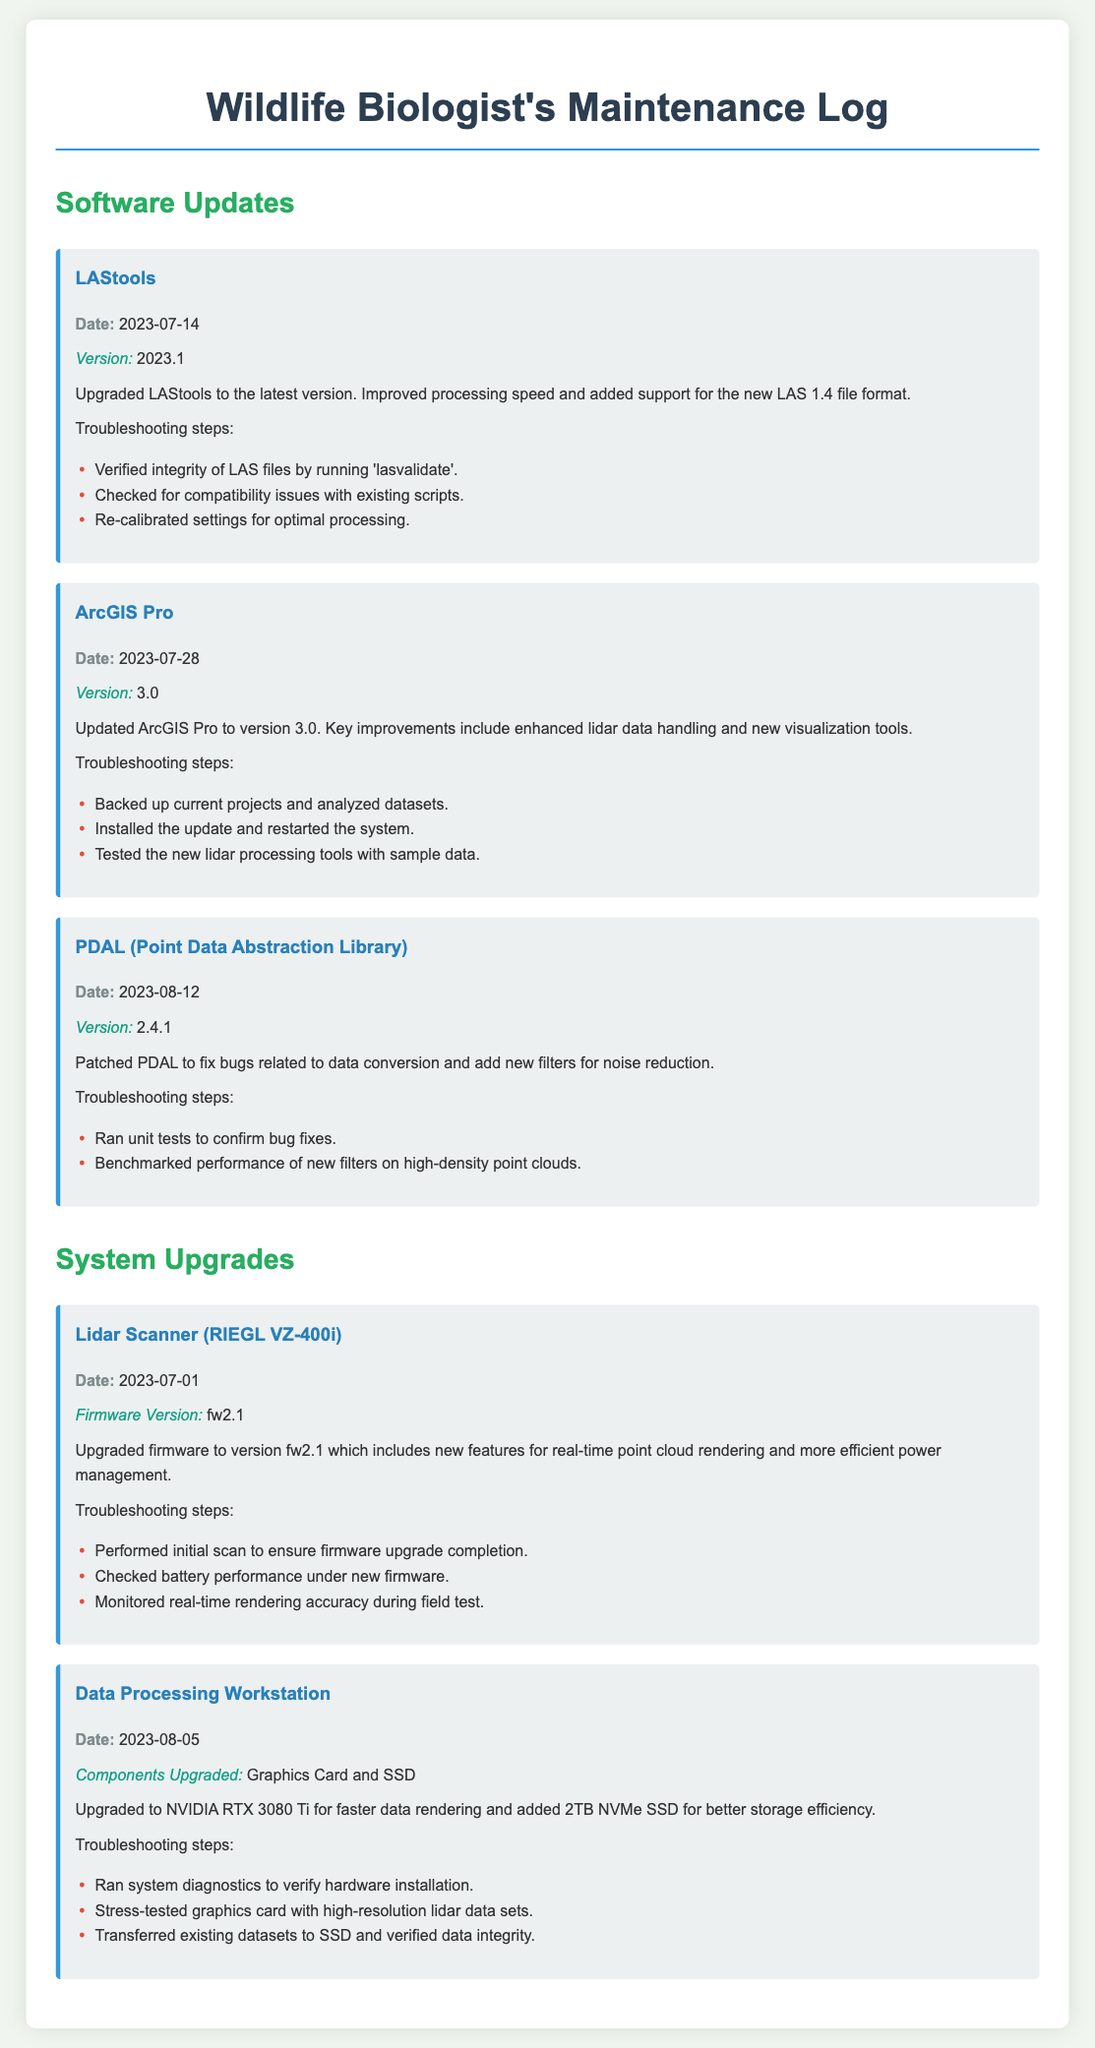what was the date of the LAStools upgrade? The LAStools upgrade is logged on July 14, 2023.
Answer: July 14, 2023 which version of ArcGIS Pro was installed? The document states that ArcGIS Pro was updated to version 3.0.
Answer: 3.0 what was the main improvement of the PDAL upgrade? The upgrade primarily fixed bugs related to data conversion and added new filters for noise reduction.
Answer: Noise reduction how many terabytes was the new SSD added to the workstation? The new SSD added to the workstation is 2TB.
Answer: 2TB what was the firmware version of the Lidar Scanner upgraded to? The Lidar Scanner firmware was upgraded to version fw2.1.
Answer: fw2.1 what troubleshooting step was taken after upgrading LAStools? The troubleshooting step mentioned is verifying the integrity of LAS files by running 'lasvalidate'.
Answer: Running 'lasvalidate' what feature was added in the LAStools upgrade? The LAStools upgrade added support for the new LAS 1.4 file format.
Answer: LAS 1.4 file format what specific component of the workstation was upgraded alongside the graphics card? The additional component upgraded was the SSD.
Answer: SSD what was the date of the Data Processing Workstation upgrade? The Data Processing Workstation was upgraded on August 5, 2023.
Answer: August 5, 2023 